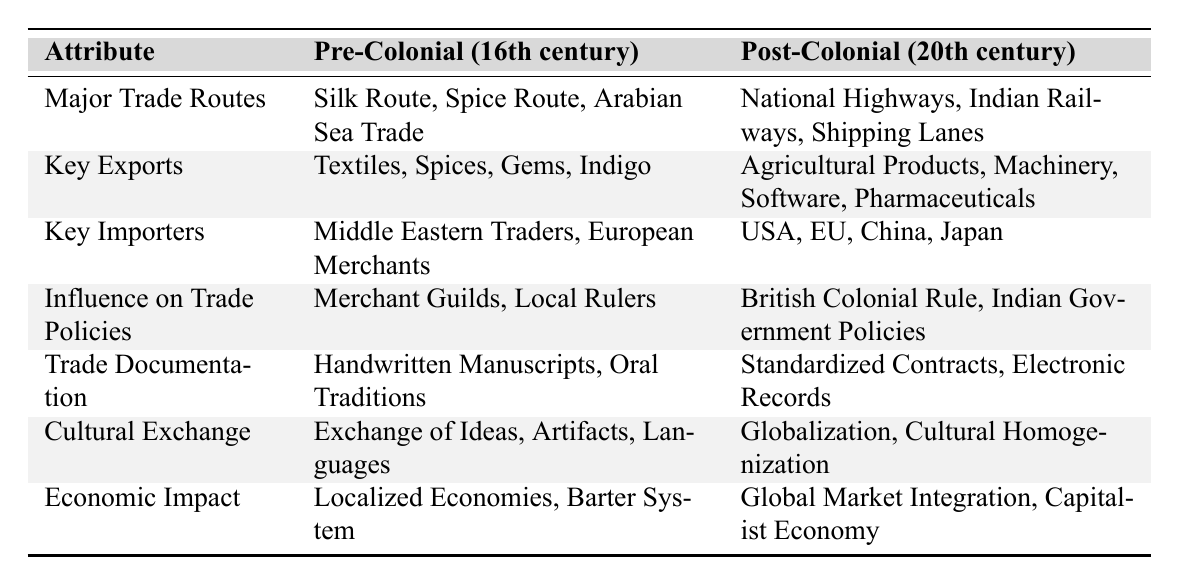What were the major trade routes in the pre-colonial period? According to the table, the major trade routes in the pre-colonial period were the Silk Route, Spice Route, and Arabian Sea Trade.
Answer: Silk Route, Spice Route, Arabian Sea Trade Which key exports were associated with the post-colonial period? The table lists Agricultural Products, Machinery, Software, and Pharmaceuticals as the key exports in the post-colonial period.
Answer: Agricultural Products, Machinery, Software, Pharmaceuticals True or false: The influence on trade policies in the pre-colonial period was mainly from British Colonial Rule. The table states that the influence on trade policies in pre-colonial times came from Merchant Guilds and Local Rulers, not British Colonial Rule, making this statement false.
Answer: False What is the difference between the key importers in the pre-colonial and post-colonial periods? In the pre-colonial period, the key importers included Middle Eastern Traders and European Merchants, while in the post-colonial period, they changed to the USA, EU, China, and Japan. The difference lies in the specific countries and regions involved.
Answer: Middle Eastern Traders vs. USA; European Merchants vs. EU, China, Japan How did trade documentation evolve from the pre-colonial to post-colonial period? The transition in trade documentation from the pre-colonial period involved moving from Handwritten Manuscripts and Oral Traditions to Standardized Contracts and Electronic Records in the post-colonial period. This shows an increase in formality and standardization.
Answer: Handwritten Manuscripts to Standardized Contracts; Oral Traditions to Electronic Records What is the significance of cultural exchange noted in the table for both time periods? The table notes that in the pre-colonial period, cultural exchange involved the exchange of Ideas, Artifacts, and Languages, while in the post-colonial period, it transformed into Globalization and Cultural Homogenization. This indicates a shift from diverse interactions to broader, unified cultural influences.
Answer: Exchange of Ideas vs. Globalization; Artifacts vs. Cultural Homogenization What economic impact did the pre-colonial and post-colonial trade systems have? The economic impact in the pre-colonial period was characterized by Localized Economies and a Barter System, while in the post-colonial period, it shifted to Global Market Integration and a Capitalist Economy, indicating an evolution to a more globalized economic framework.
Answer: Localized Economies to Global Market Integration; Barter System to Capitalist Economy Which key exports in the pre-colonial period have counterparts in the post-colonial period? Textiles in the pre-colonial period has a loose counterpart in Agricultural Products, as both are primary goods; Spices in pre-colonial may relate to Machinery in terms of being significant exports, however, they differ in nature and usage.
Answer: Textiles to Agricultural Products; Spices to Machinery 